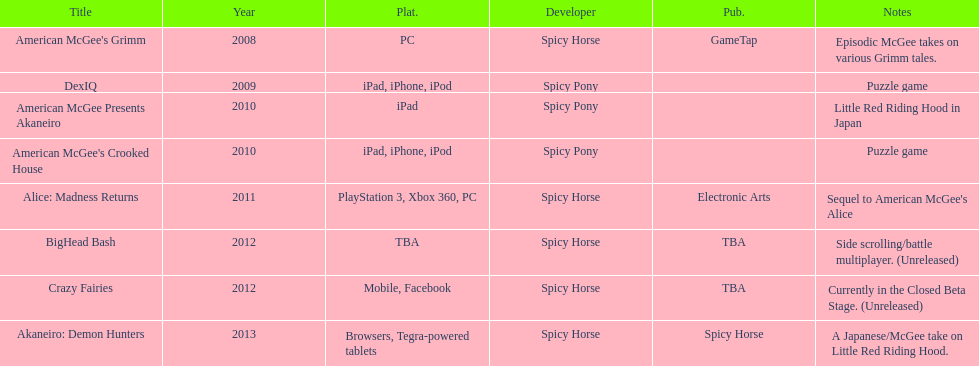Can you parse all the data within this table? {'header': ['Title', 'Year', 'Plat.', 'Developer', 'Pub.', 'Notes'], 'rows': [["American McGee's Grimm", '2008', 'PC', 'Spicy Horse', 'GameTap', 'Episodic McGee takes on various Grimm tales.'], ['DexIQ', '2009', 'iPad, iPhone, iPod', 'Spicy Pony', '', 'Puzzle game'], ['American McGee Presents Akaneiro', '2010', 'iPad', 'Spicy Pony', '', 'Little Red Riding Hood in Japan'], ["American McGee's Crooked House", '2010', 'iPad, iPhone, iPod', 'Spicy Pony', '', 'Puzzle game'], ['Alice: Madness Returns', '2011', 'PlayStation 3, Xbox 360, PC', 'Spicy Horse', 'Electronic Arts', "Sequel to American McGee's Alice"], ['BigHead Bash', '2012', 'TBA', 'Spicy Horse', 'TBA', 'Side scrolling/battle multiplayer. (Unreleased)'], ['Crazy Fairies', '2012', 'Mobile, Facebook', 'Spicy Horse', 'TBA', 'Currently in the Closed Beta Stage. (Unreleased)'], ['Akaneiro: Demon Hunters', '2013', 'Browsers, Tegra-powered tablets', 'Spicy Horse', 'Spicy Horse', 'A Japanese/McGee take on Little Red Riding Hood.']]} What year had a total of 2 titles released? 2010. 